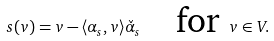Convert formula to latex. <formula><loc_0><loc_0><loc_500><loc_500>s ( v ) = v - \langle \alpha _ { s } , v \rangle \check { \alpha } _ { s } \quad \text {for } v \in V .</formula> 